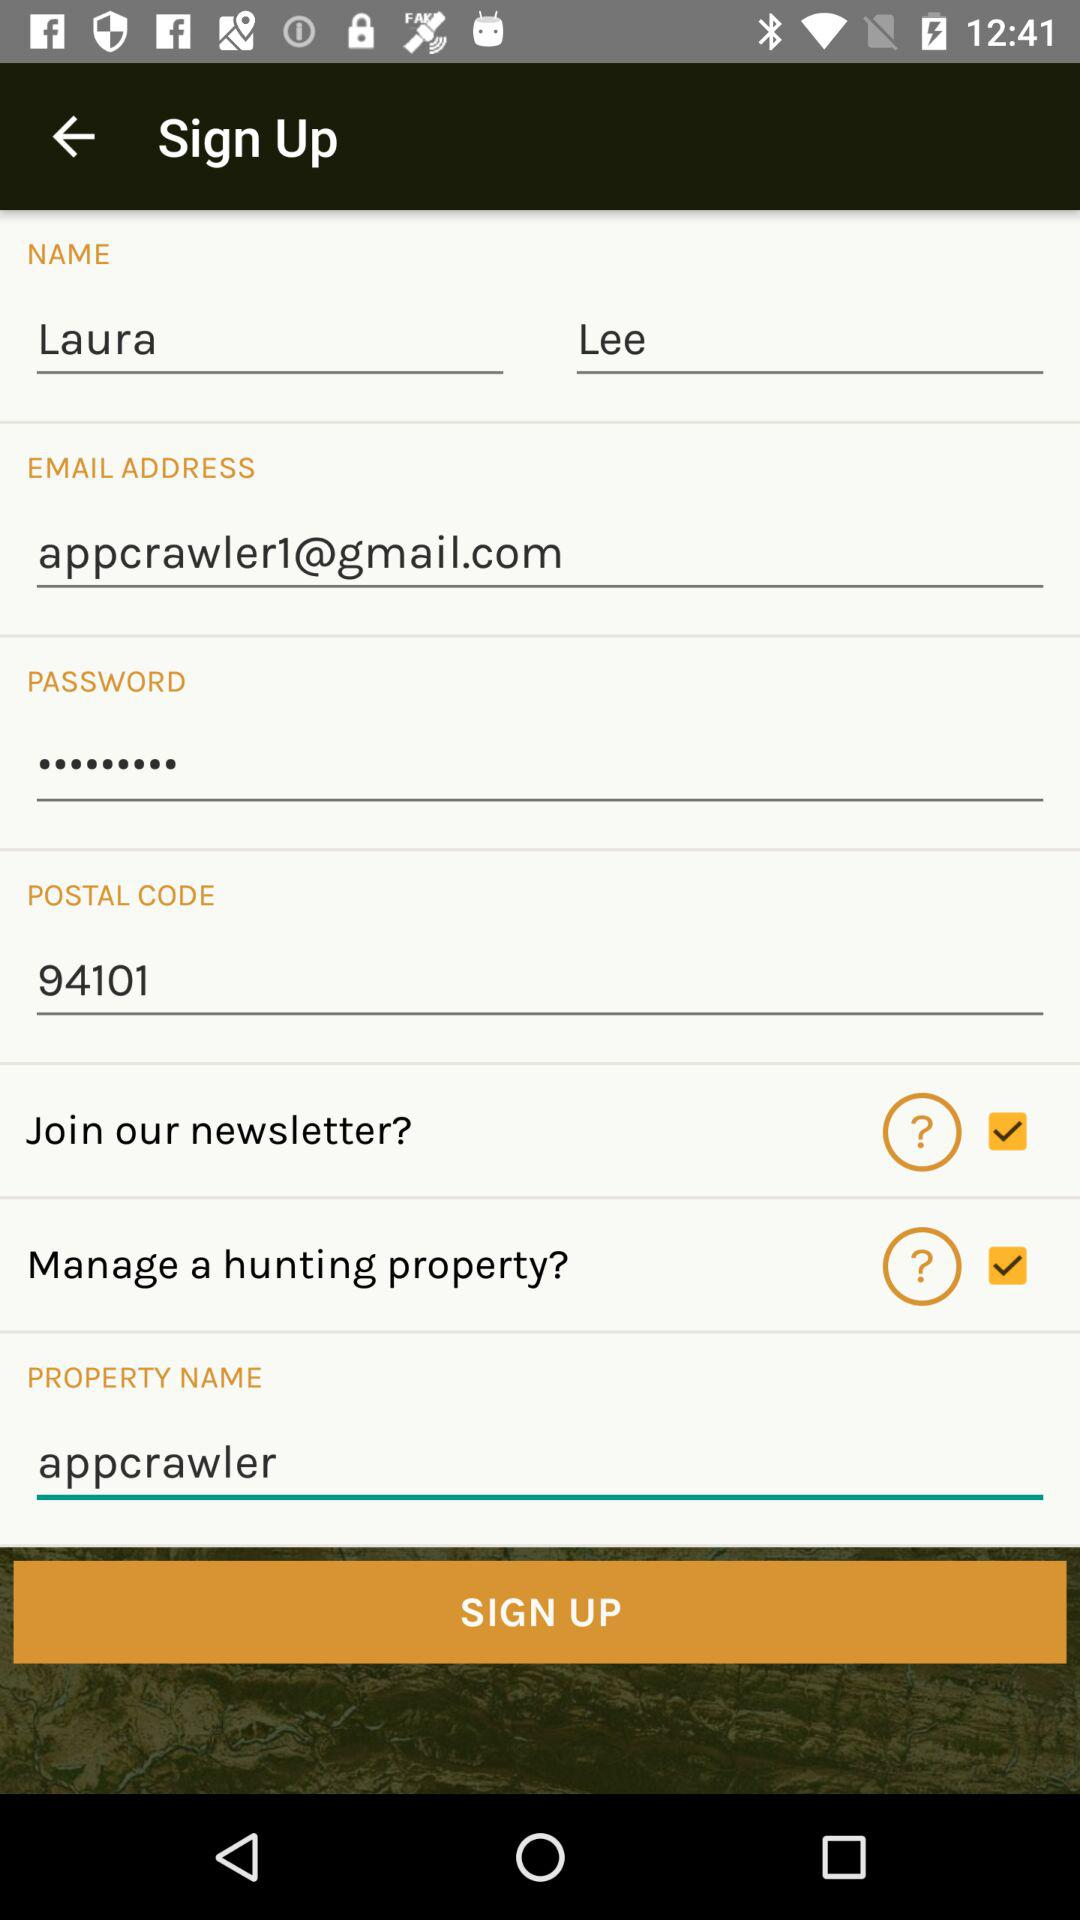What is the email address? The email address is appcrawler1@gmail.com. 